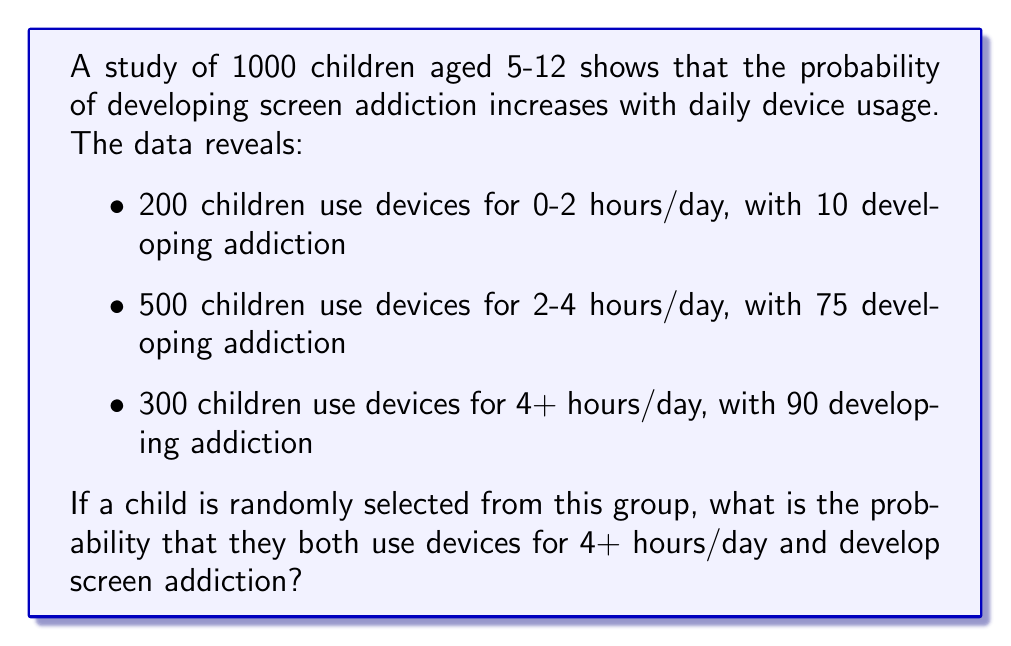Can you answer this question? To solve this problem, we'll use the concept of joint probability.

Step 1: Calculate the probability of a child using devices for 4+ hours/day
$P(\text{4+ hours}) = \frac{300}{1000} = 0.3$

Step 2: Calculate the probability of developing addiction given 4+ hours of use
$P(\text{addiction | 4+ hours}) = \frac{90}{300} = 0.3$

Step 3: Calculate the joint probability using the multiplication rule
$P(\text{4+ hours and addiction}) = P(\text{4+ hours}) \times P(\text{addiction | 4+ hours})$
$P(\text{4+ hours and addiction}) = 0.3 \times 0.3 = 0.09$

Therefore, the probability that a randomly selected child both uses devices for 4+ hours/day and develops screen addiction is 0.09 or 9%.
Answer: 0.09 